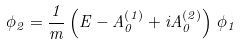<formula> <loc_0><loc_0><loc_500><loc_500>\phi _ { 2 } = \frac { 1 } { m } \left ( E - A _ { 0 } ^ { \left ( 1 \right ) } + i A _ { 0 } ^ { \left ( 2 \right ) } \right ) \, \phi _ { 1 }</formula> 